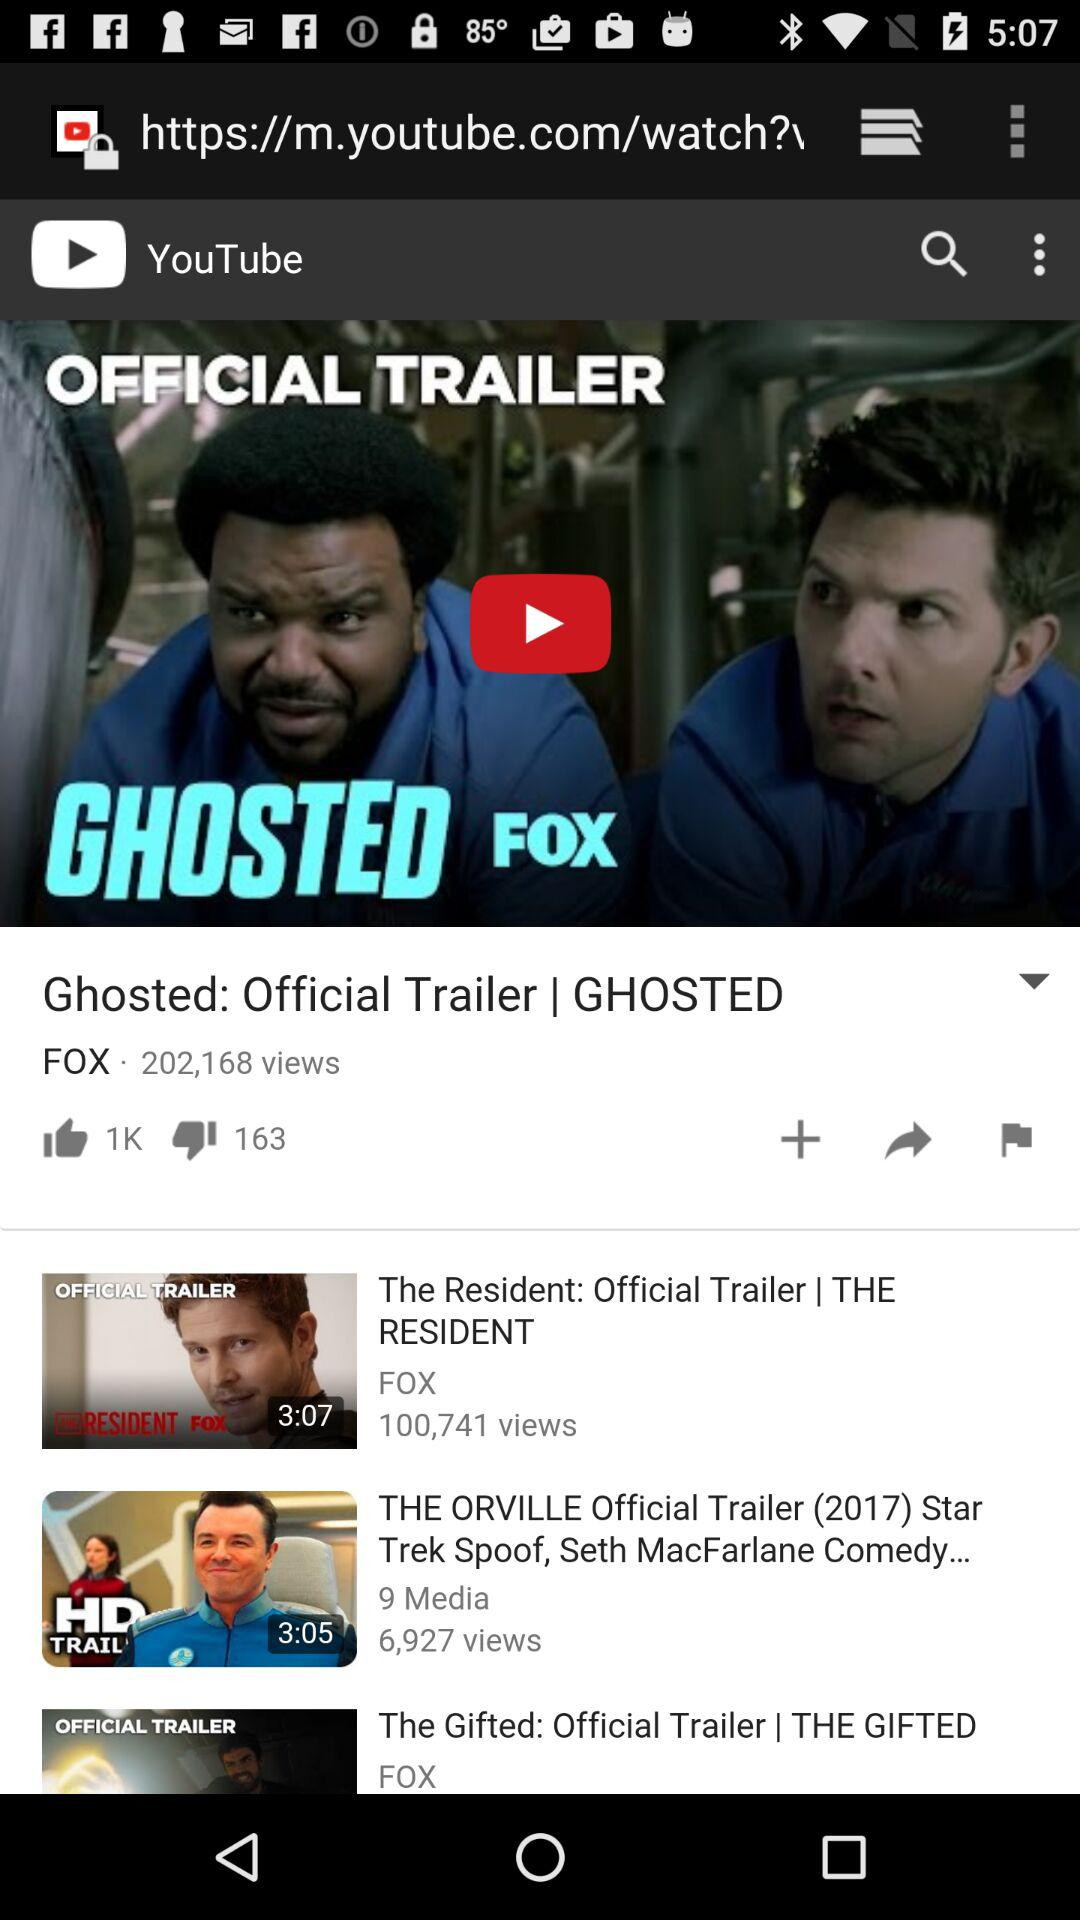How many thumbs down does the video have?
Answer the question using a single word or phrase. 163 